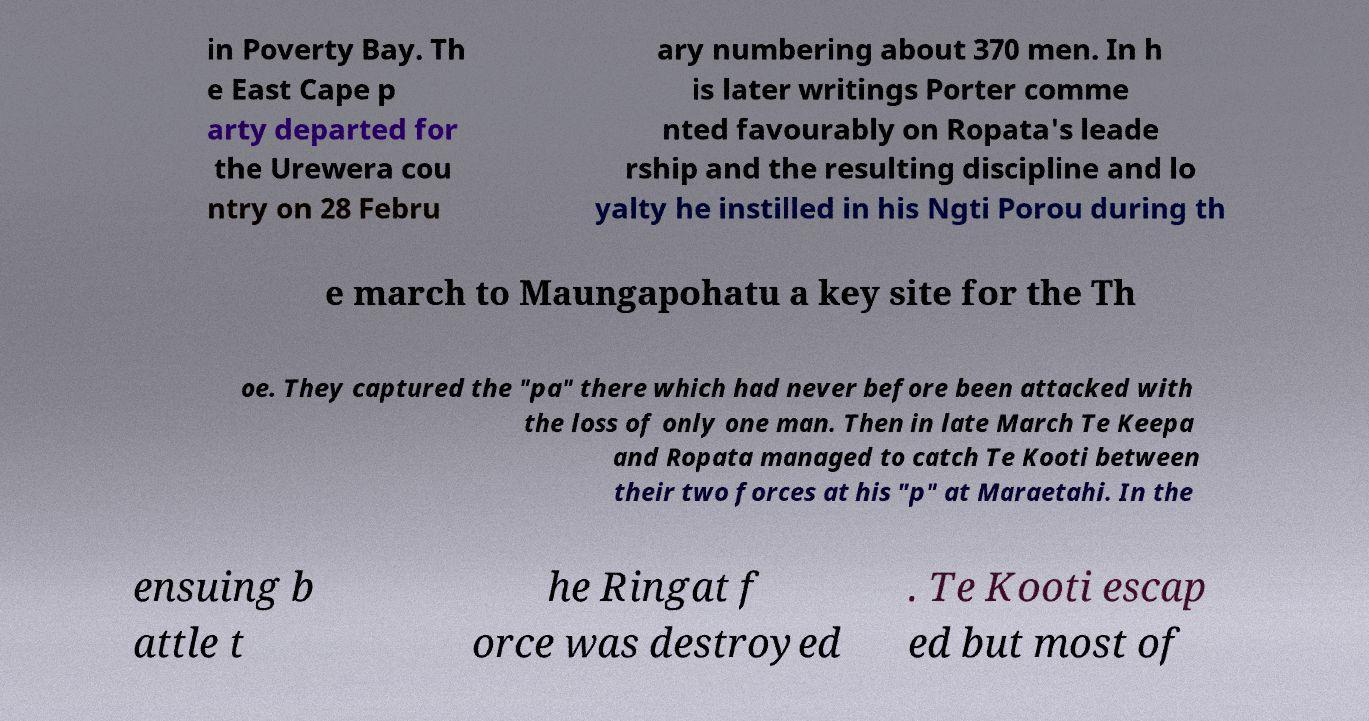Can you read and provide the text displayed in the image?This photo seems to have some interesting text. Can you extract and type it out for me? in Poverty Bay. Th e East Cape p arty departed for the Urewera cou ntry on 28 Febru ary numbering about 370 men. In h is later writings Porter comme nted favourably on Ropata's leade rship and the resulting discipline and lo yalty he instilled in his Ngti Porou during th e march to Maungapohatu a key site for the Th oe. They captured the "pa" there which had never before been attacked with the loss of only one man. Then in late March Te Keepa and Ropata managed to catch Te Kooti between their two forces at his "p" at Maraetahi. In the ensuing b attle t he Ringat f orce was destroyed . Te Kooti escap ed but most of 